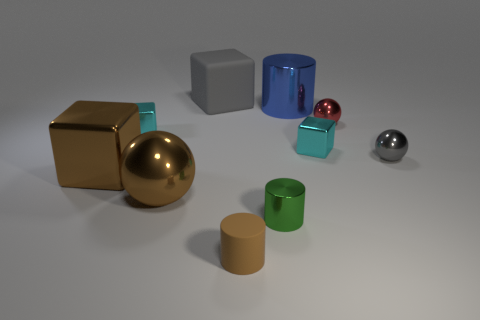What is the shape of the shiny object that is the same color as the big ball?
Provide a succinct answer. Cube. What is the size of the metallic sphere that is the same color as the rubber block?
Your answer should be very brief. Small. Is the number of large gray blocks that are in front of the tiny red metal thing less than the number of gray shiny cylinders?
Keep it short and to the point. No. There is a large cylinder; what number of small cyan shiny cubes are left of it?
Provide a short and direct response. 1. Does the rubber thing behind the brown rubber thing have the same shape as the cyan shiny object on the right side of the big gray object?
Offer a terse response. Yes. There is a small thing that is left of the small metal cylinder and to the right of the big matte block; what is its shape?
Offer a terse response. Cylinder. There is a gray thing that is the same material as the small red ball; what size is it?
Provide a succinct answer. Small. Is the number of big purple rubber cylinders less than the number of cylinders?
Your answer should be compact. Yes. The large thing right of the brown thing that is right of the thing that is behind the large shiny cylinder is made of what material?
Offer a terse response. Metal. Do the small red sphere that is to the right of the large gray rubber block and the cylinder behind the brown cube have the same material?
Provide a succinct answer. Yes. 